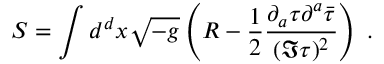<formula> <loc_0><loc_0><loc_500><loc_500>S = \int d ^ { d } x \sqrt { - g } \left ( R - \frac { 1 } { 2 } \frac { \partial _ { a } \tau \partial ^ { a } \bar { \tau } } { ( \Im \tau ) ^ { 2 } } \right ) \, .</formula> 